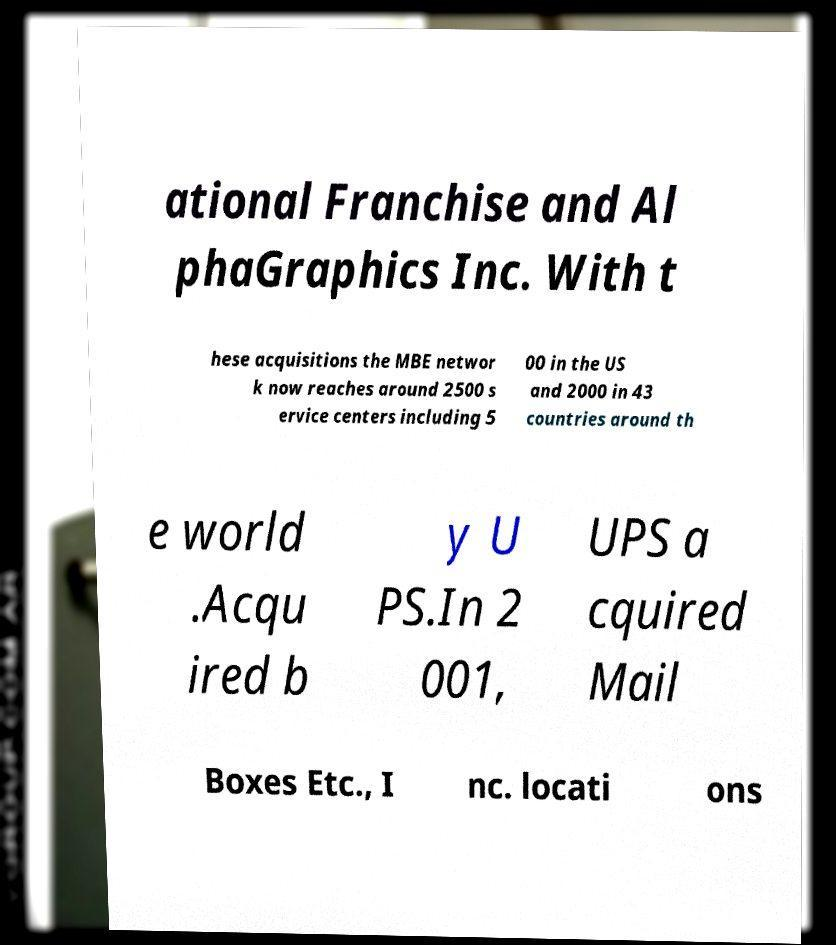Can you read and provide the text displayed in the image?This photo seems to have some interesting text. Can you extract and type it out for me? ational Franchise and Al phaGraphics Inc. With t hese acquisitions the MBE networ k now reaches around 2500 s ervice centers including 5 00 in the US and 2000 in 43 countries around th e world .Acqu ired b y U PS.In 2 001, UPS a cquired Mail Boxes Etc., I nc. locati ons 